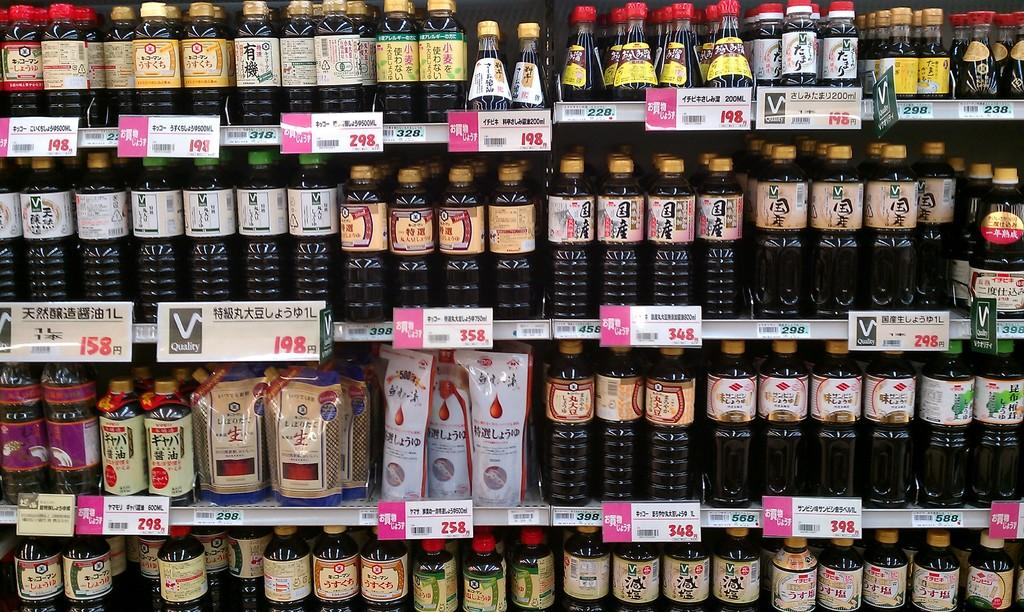<image>
Write a terse but informative summary of the picture. A selection of beverages at a store shows a few different options for 198. 